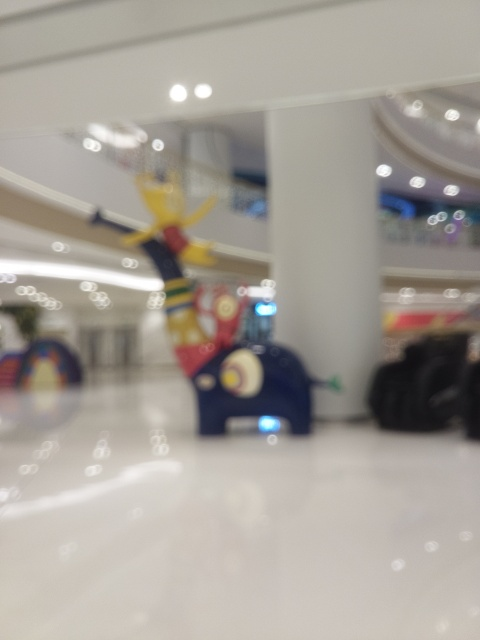What is the object in the foreground, and does it seem to be the main subject of the photo? The object in the foreground appears to be a colorful sculpture, possibly an artistic installation, and it indeed seems to be the main subject of the photo. The photographer has intentionally focused on this, using a photographic technique to blur the background and draw attention to it. 